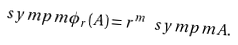Convert formula to latex. <formula><loc_0><loc_0><loc_500><loc_500>\ s y m p { m } { \phi _ { r } ( \AA A ) } = r ^ { m } \ s y m p { m } { \AA A } .</formula> 